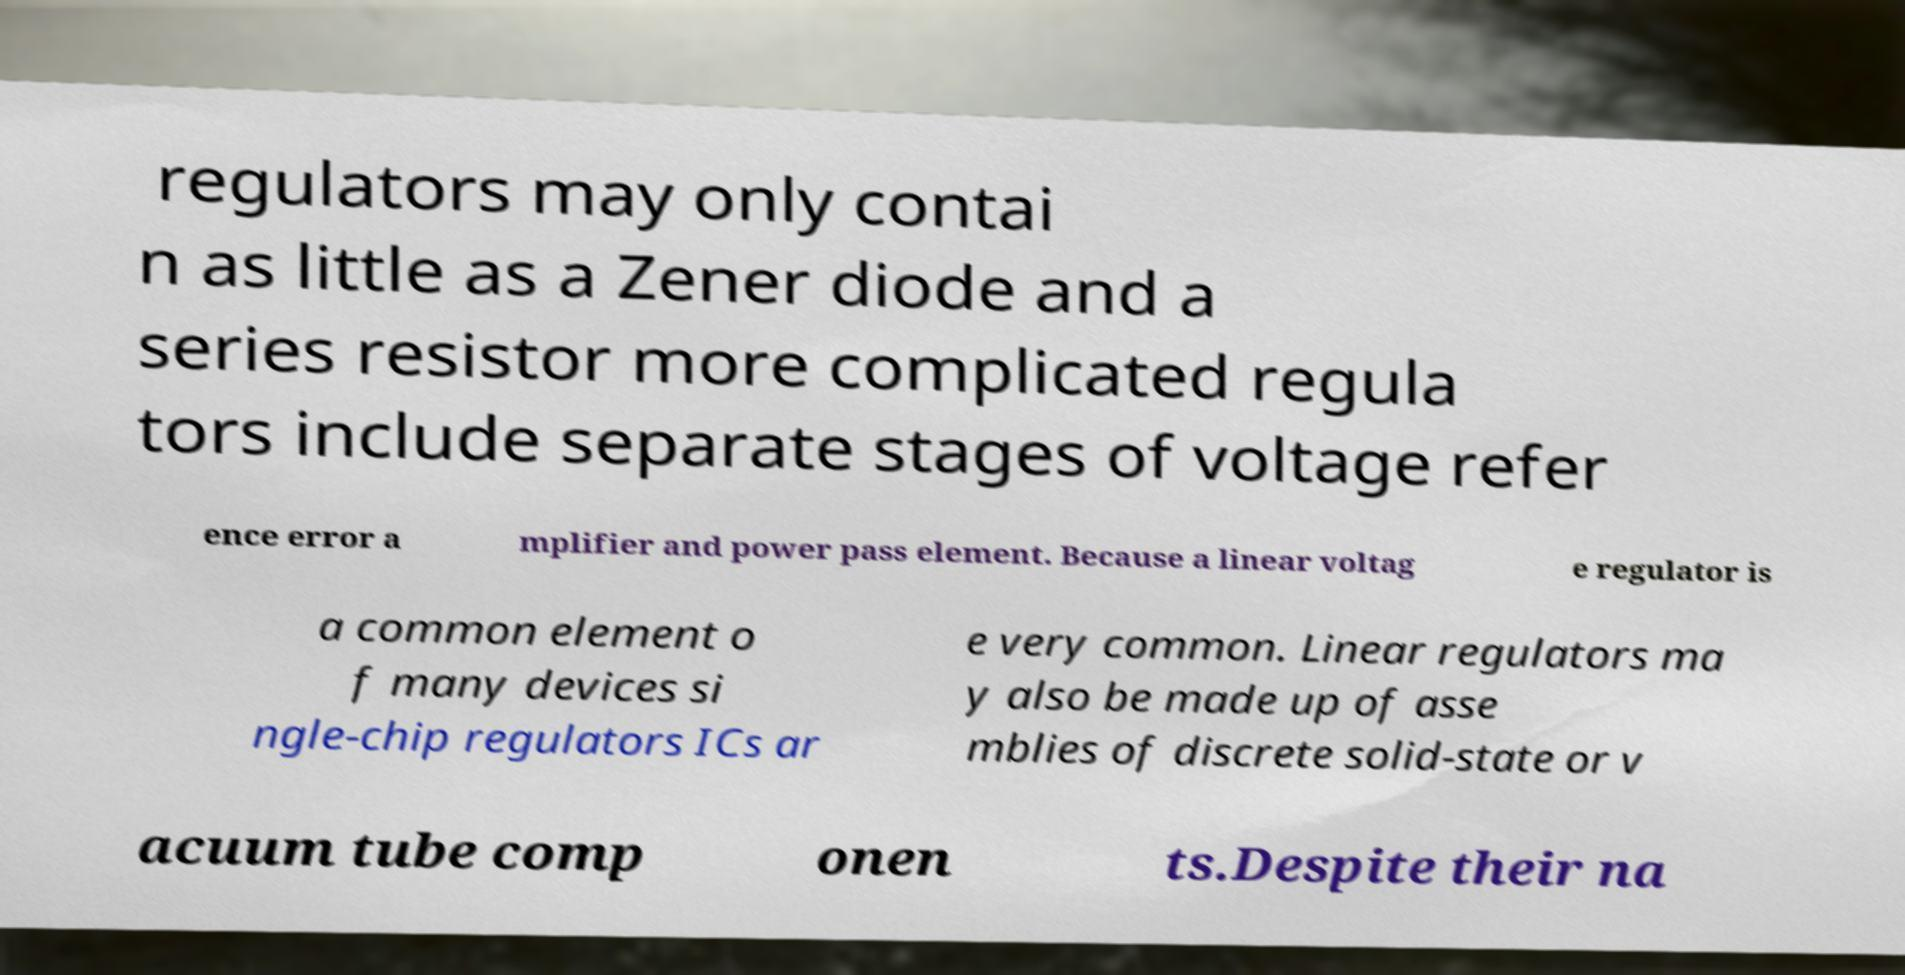Can you read and provide the text displayed in the image?This photo seems to have some interesting text. Can you extract and type it out for me? regulators may only contai n as little as a Zener diode and a series resistor more complicated regula tors include separate stages of voltage refer ence error a mplifier and power pass element. Because a linear voltag e regulator is a common element o f many devices si ngle-chip regulators ICs ar e very common. Linear regulators ma y also be made up of asse mblies of discrete solid-state or v acuum tube comp onen ts.Despite their na 